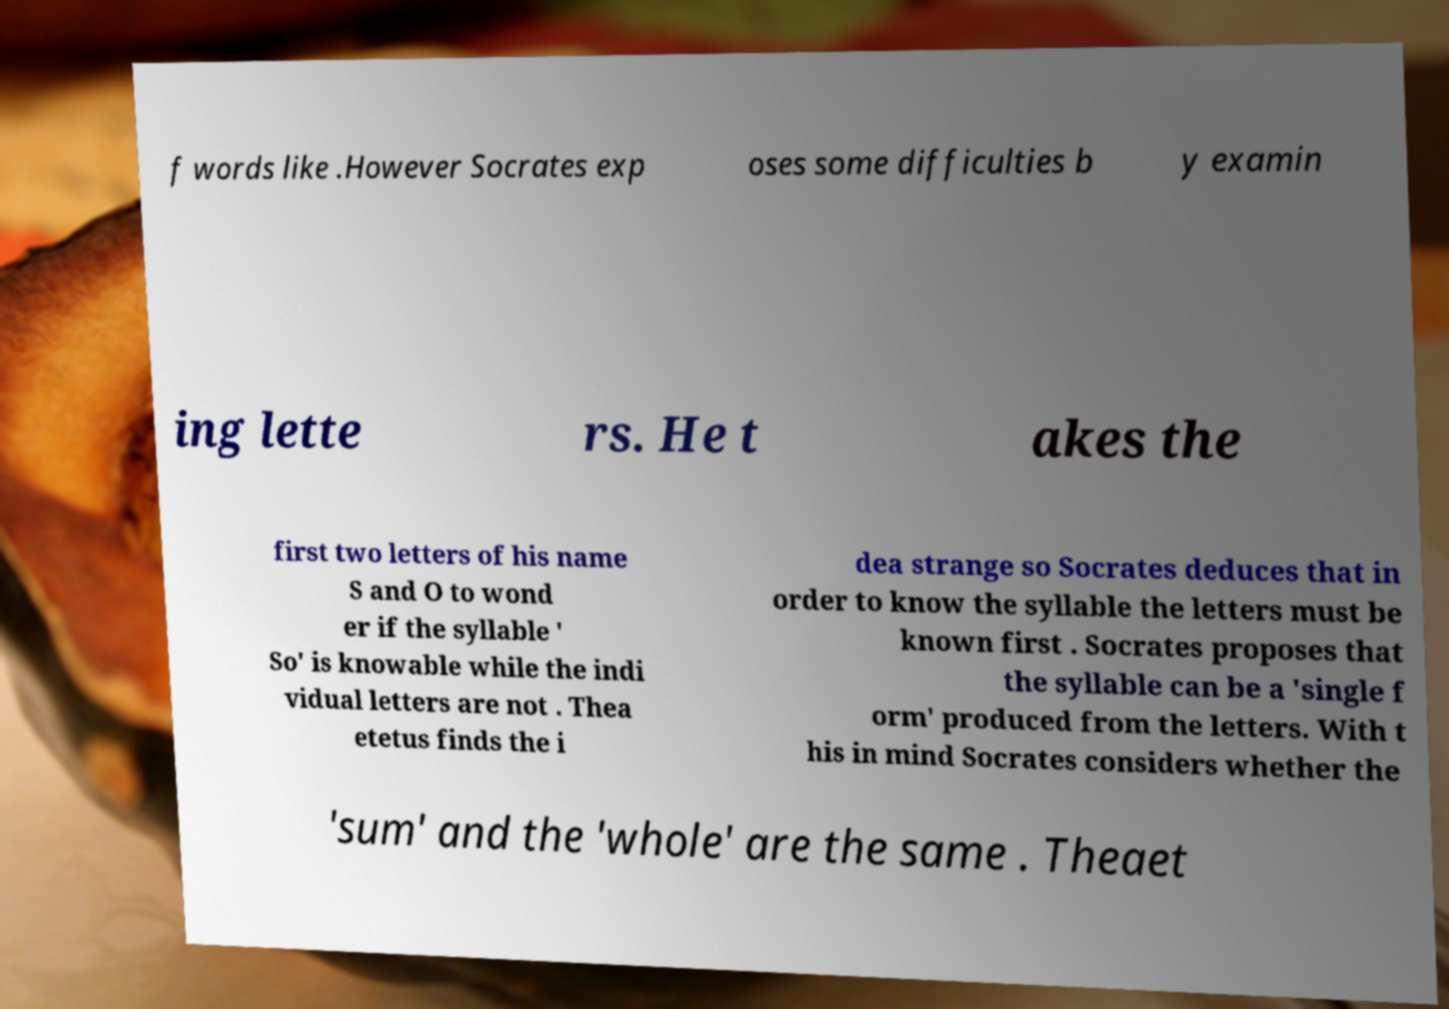Could you assist in decoding the text presented in this image and type it out clearly? f words like .However Socrates exp oses some difficulties b y examin ing lette rs. He t akes the first two letters of his name S and O to wond er if the syllable ' So' is knowable while the indi vidual letters are not . Thea etetus finds the i dea strange so Socrates deduces that in order to know the syllable the letters must be known first . Socrates proposes that the syllable can be a 'single f orm' produced from the letters. With t his in mind Socrates considers whether the 'sum' and the 'whole' are the same . Theaet 